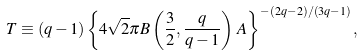Convert formula to latex. <formula><loc_0><loc_0><loc_500><loc_500>T \equiv ( q - 1 ) \left \{ 4 \sqrt { 2 } \pi B \left ( \frac { 3 } { 2 } , \frac { q } { q - 1 } \right ) \, A \right \} ^ { - ( 2 q - 2 ) / ( 3 q - 1 ) } ,</formula> 